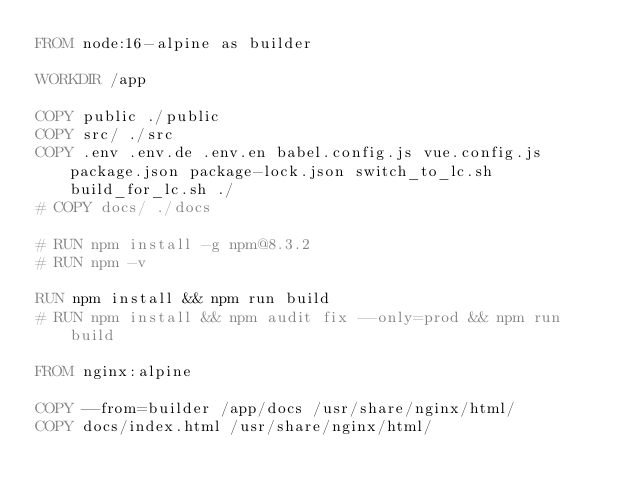<code> <loc_0><loc_0><loc_500><loc_500><_Dockerfile_>FROM node:16-alpine as builder

WORKDIR /app

COPY public ./public
COPY src/ ./src
COPY .env .env.de .env.en babel.config.js vue.config.js package.json package-lock.json switch_to_lc.sh build_for_lc.sh ./
# COPY docs/ ./docs

# RUN npm install -g npm@8.3.2
# RUN npm -v

RUN npm install && npm run build
# RUN npm install && npm audit fix --only=prod && npm run build

FROM nginx:alpine

COPY --from=builder /app/docs /usr/share/nginx/html/
COPY docs/index.html /usr/share/nginx/html/</code> 